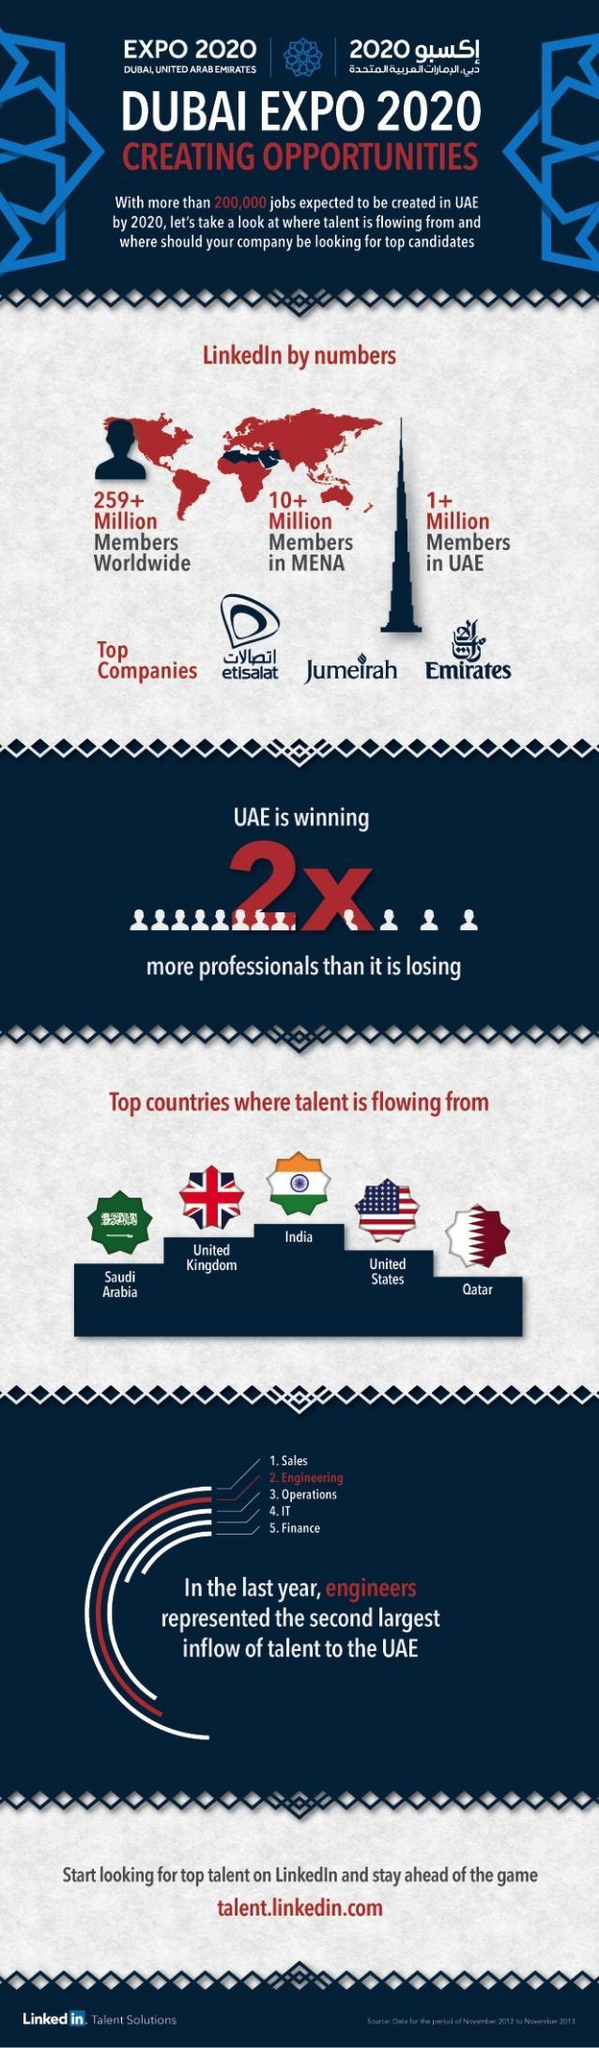WHat category is the third largest inflow of talents
Answer the question with a short phrase. Operations How many linkedin members worldwide 259+ million Which is the company for telecommunication in UAE Etisalat For every single talent lost, how many talents is UAE winning 2 Which country after India has the most talents being flown into UAE united kingdom 